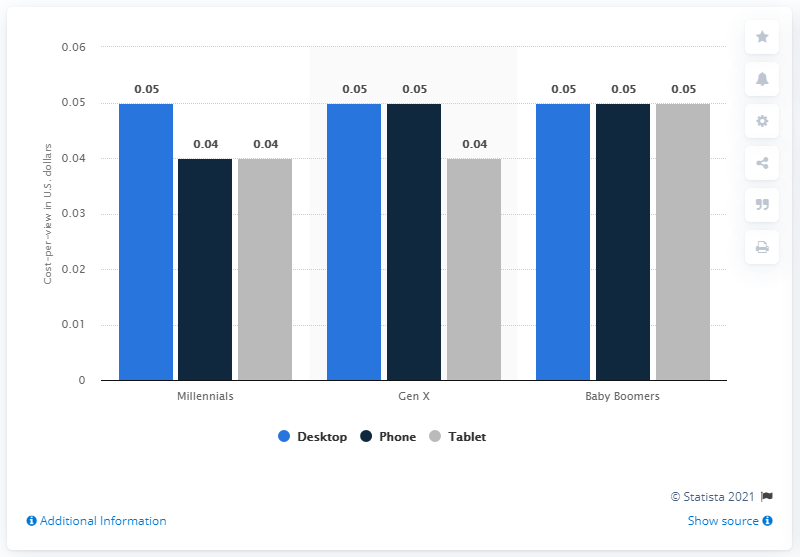Draw attention to some important aspects in this diagram. The average cost per view (CPV) of YouTube ads viewed by Millennials on desktop was 0.05. 